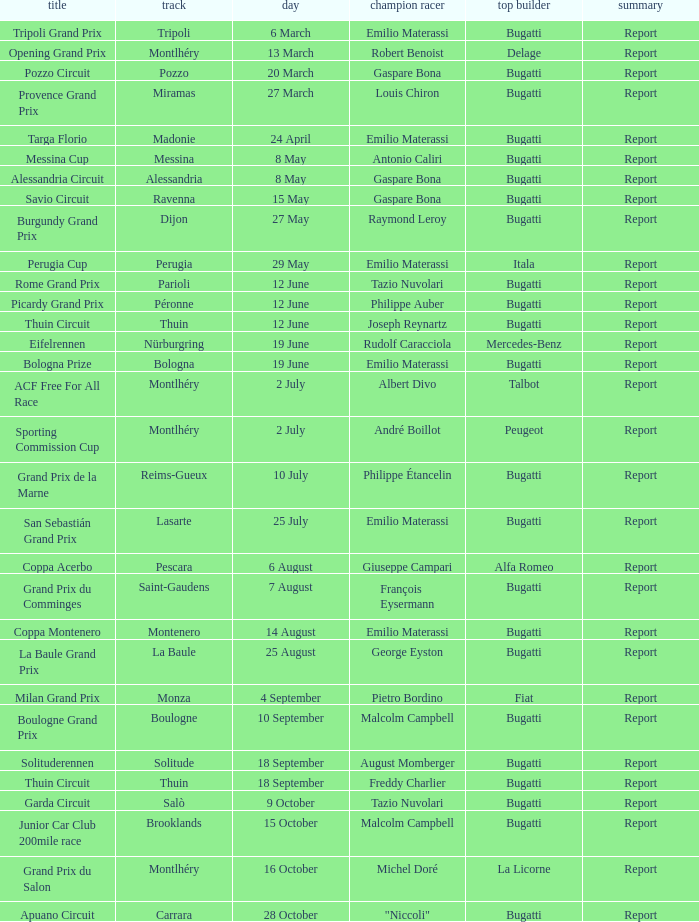Who was the winning constructor of the Grand Prix Du Salon ? La Licorne. 